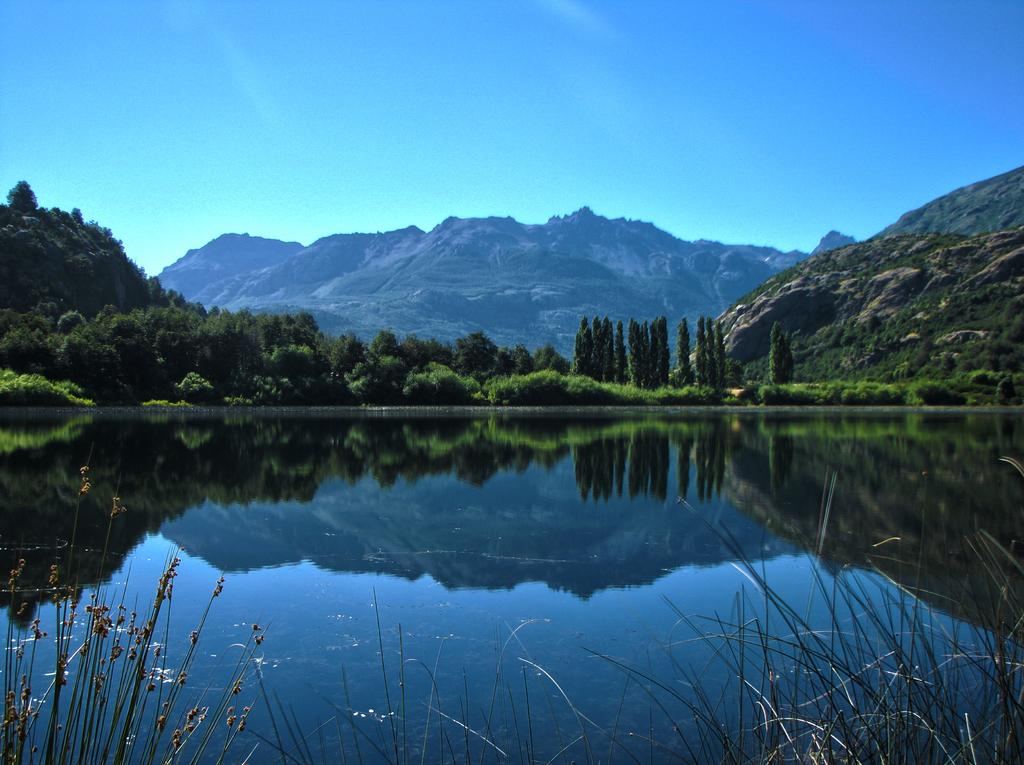What is present in the image that covers a large portion of it? There is water in the image. What type of natural vegetation can be seen in the image? There are trees visible in the image. What type of landscape feature is visible in the background of the image? There are mountains in the background of the image. What part of the natural environment is visible in the background of the image? The sky is visible in the background of the image. What can be observed on the water's surface in the image? There is a reflection on the water in the image. What type of pot is being used to transport the mountains in the image? There is no pot or transportation of mountains in the image; it features water, trees, mountains, and a sky. 